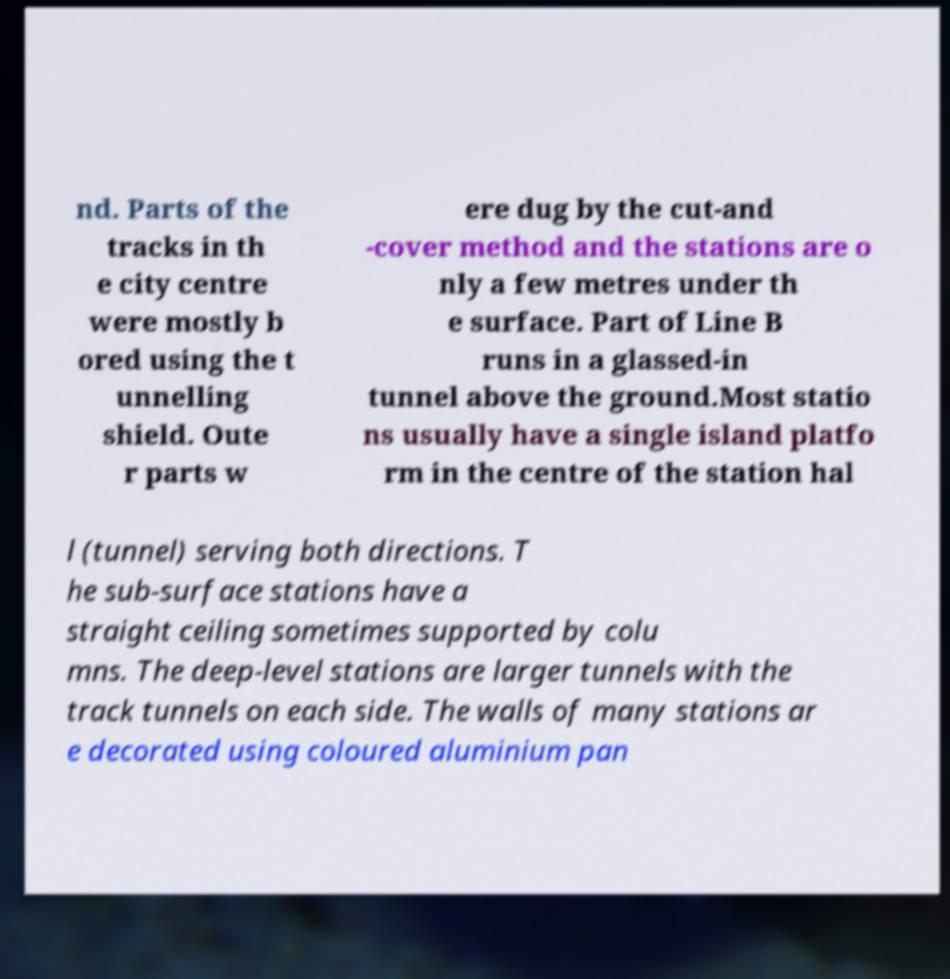There's text embedded in this image that I need extracted. Can you transcribe it verbatim? nd. Parts of the tracks in th e city centre were mostly b ored using the t unnelling shield. Oute r parts w ere dug by the cut-and -cover method and the stations are o nly a few metres under th e surface. Part of Line B runs in a glassed-in tunnel above the ground.Most statio ns usually have a single island platfo rm in the centre of the station hal l (tunnel) serving both directions. T he sub-surface stations have a straight ceiling sometimes supported by colu mns. The deep-level stations are larger tunnels with the track tunnels on each side. The walls of many stations ar e decorated using coloured aluminium pan 